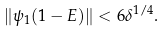Convert formula to latex. <formula><loc_0><loc_0><loc_500><loc_500>\| \psi _ { 1 } ( 1 - E ) \| < 6 \delta ^ { 1 / 4 } .</formula> 